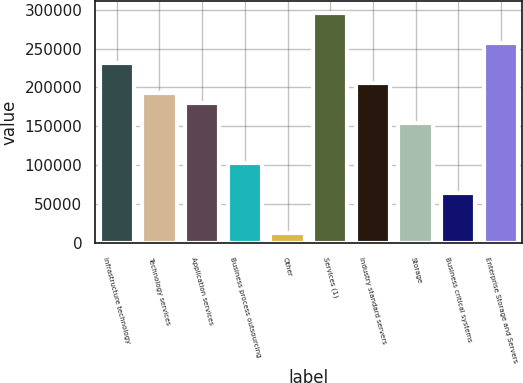<chart> <loc_0><loc_0><loc_500><loc_500><bar_chart><fcel>Infrastructure technology<fcel>Technology services<fcel>Application services<fcel>Business process outsourcing<fcel>Other<fcel>Services (1)<fcel>Industry standard servers<fcel>Storage<fcel>Business critical systems<fcel>Enterprise Storage and Servers<nl><fcel>231387<fcel>192837<fcel>179987<fcel>102887<fcel>12937<fcel>295637<fcel>205687<fcel>154287<fcel>64337<fcel>257087<nl></chart> 